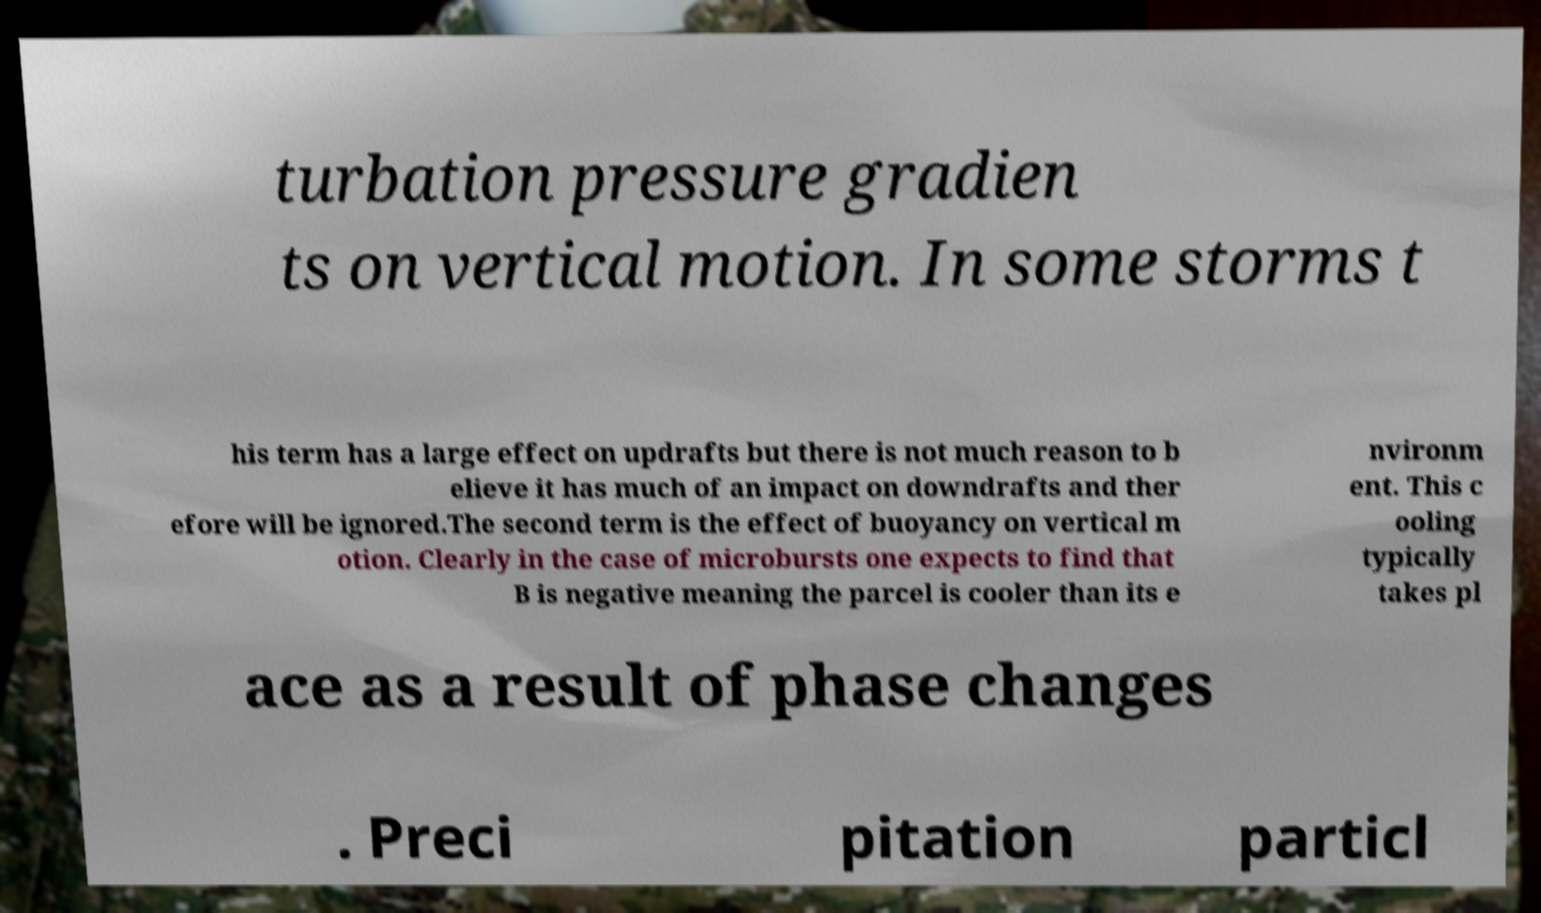Please identify and transcribe the text found in this image. turbation pressure gradien ts on vertical motion. In some storms t his term has a large effect on updrafts but there is not much reason to b elieve it has much of an impact on downdrafts and ther efore will be ignored.The second term is the effect of buoyancy on vertical m otion. Clearly in the case of microbursts one expects to find that B is negative meaning the parcel is cooler than its e nvironm ent. This c ooling typically takes pl ace as a result of phase changes . Preci pitation particl 